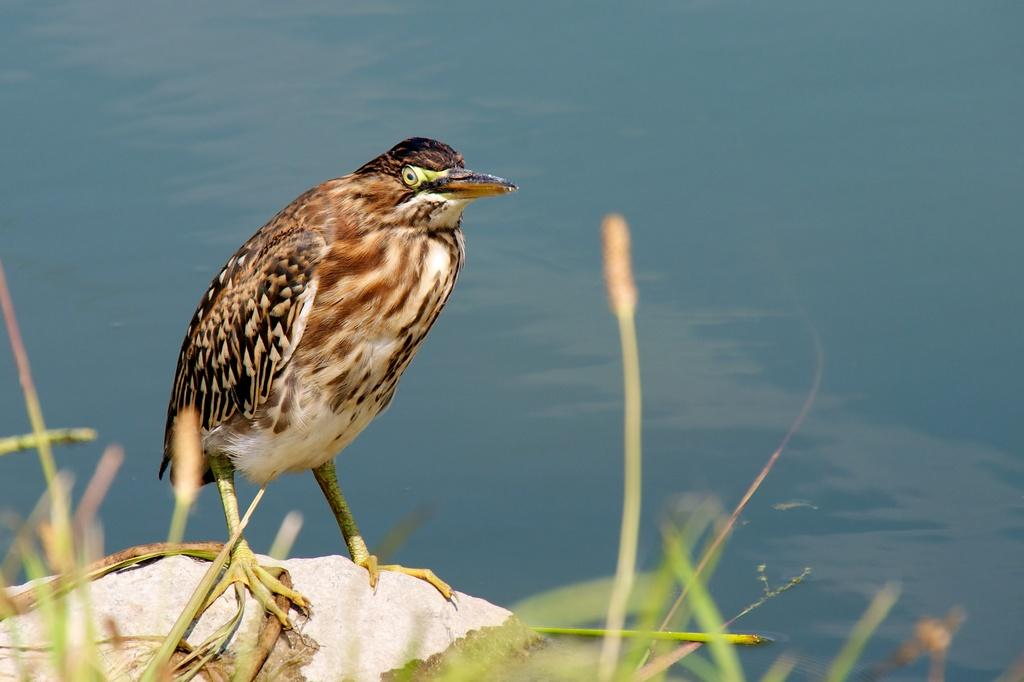What type of animal can be seen in the image? There is a bird in the image. Where is the bird located? The bird is on a rock. What can be seen behind the bird? There is water visible behind the bird. What type of vegetation is at the bottom of the image? There is grass at the bottom of the image. What is the price of the bird in the image? There is no price associated with the bird in the image, as it is a photograph and not a product for sale. 